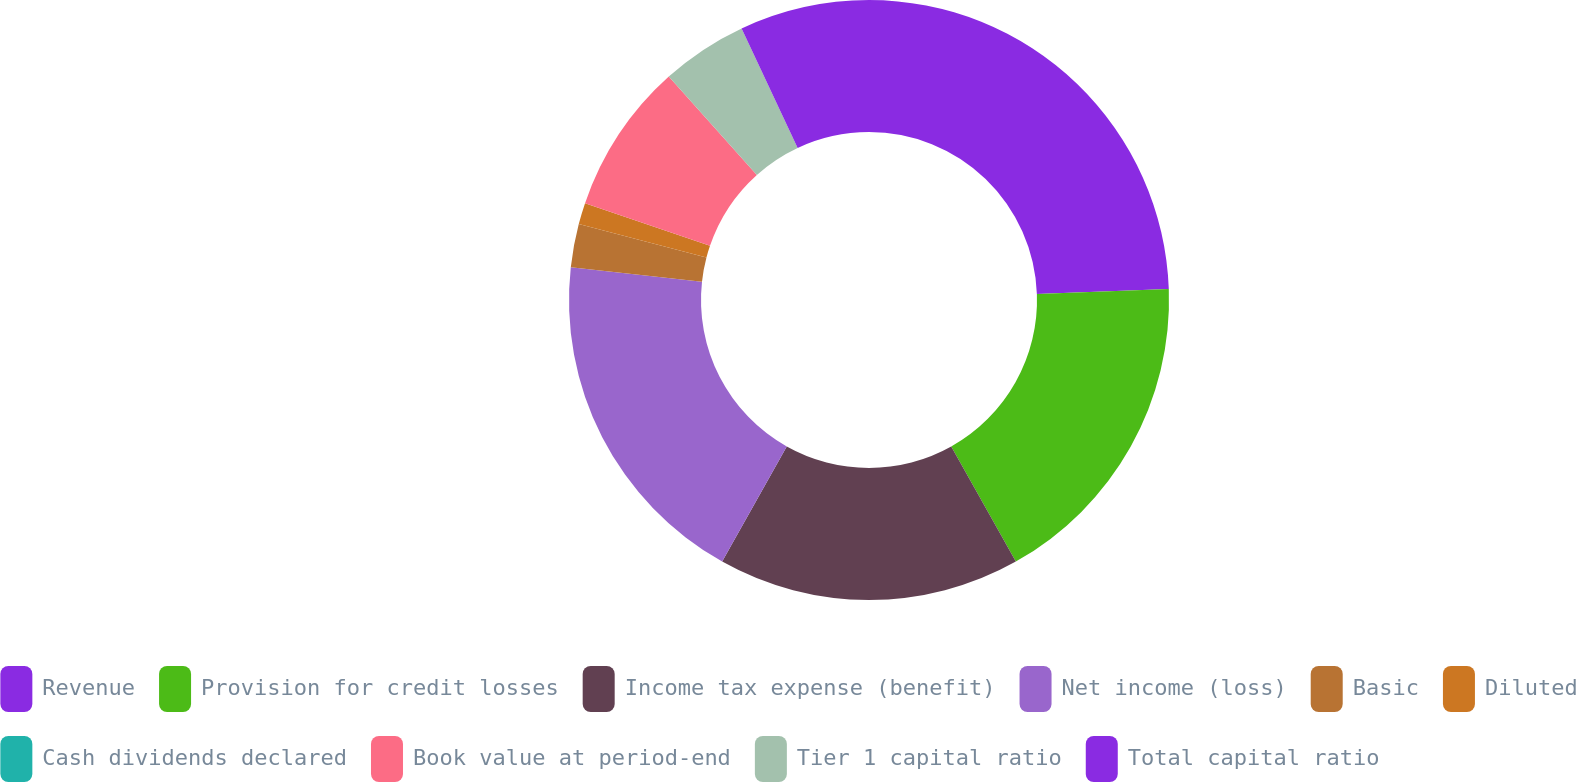Convert chart. <chart><loc_0><loc_0><loc_500><loc_500><pie_chart><fcel>Revenue<fcel>Provision for credit losses<fcel>Income tax expense (benefit)<fcel>Net income (loss)<fcel>Basic<fcel>Diluted<fcel>Cash dividends declared<fcel>Book value at period-end<fcel>Tier 1 capital ratio<fcel>Total capital ratio<nl><fcel>24.42%<fcel>17.44%<fcel>16.28%<fcel>18.6%<fcel>2.33%<fcel>1.16%<fcel>0.0%<fcel>8.14%<fcel>4.65%<fcel>6.98%<nl></chart> 